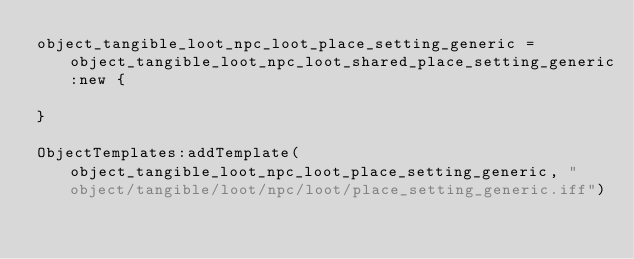<code> <loc_0><loc_0><loc_500><loc_500><_Lua_>object_tangible_loot_npc_loot_place_setting_generic = object_tangible_loot_npc_loot_shared_place_setting_generic:new {

}

ObjectTemplates:addTemplate(object_tangible_loot_npc_loot_place_setting_generic, "object/tangible/loot/npc/loot/place_setting_generic.iff")
</code> 